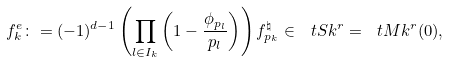<formula> <loc_0><loc_0><loc_500><loc_500>f ^ { e } _ { k } \colon = ( - 1 ) ^ { d - 1 } \left ( \prod _ { l \in I _ { k } } \left ( 1 - \frac { \phi _ { p _ { l } } } { p _ { l } } \right ) \right ) f ^ { \natural } _ { p _ { k } } \in \ t S k ^ { r } = \ t M k ^ { r } ( 0 ) ,</formula> 